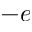Convert formula to latex. <formula><loc_0><loc_0><loc_500><loc_500>- e</formula> 